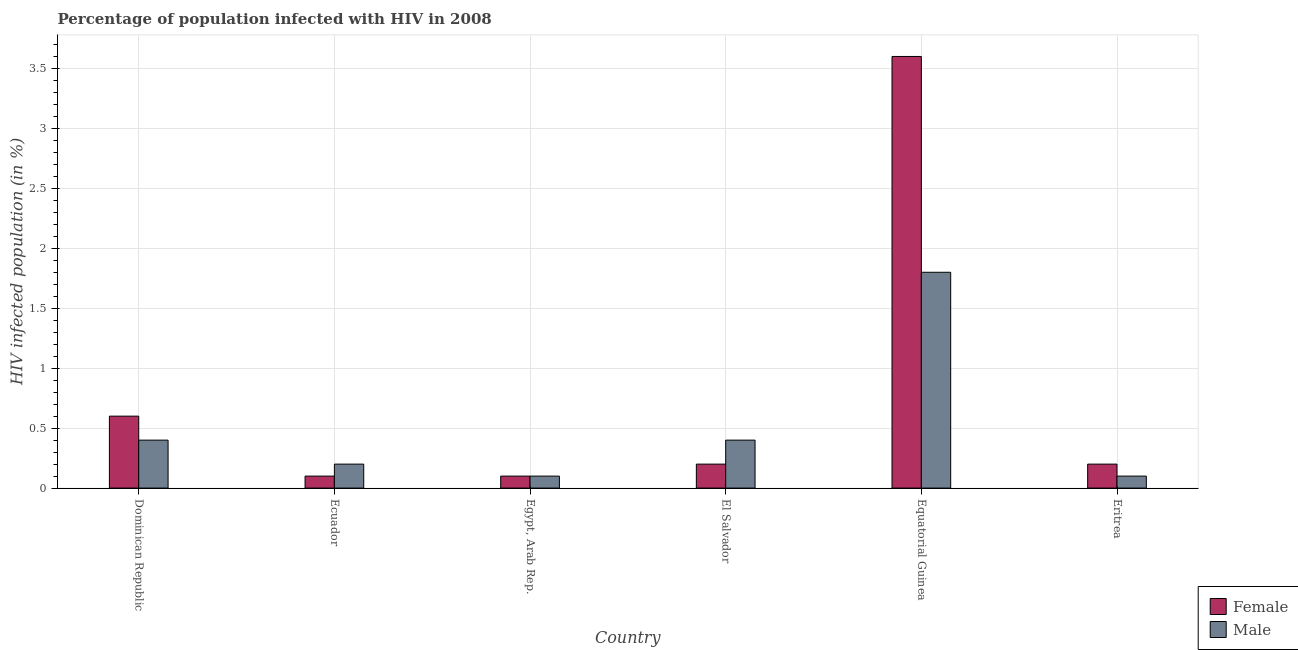How many groups of bars are there?
Keep it short and to the point. 6. How many bars are there on the 1st tick from the right?
Your answer should be compact. 2. What is the label of the 6th group of bars from the left?
Your answer should be very brief. Eritrea. In how many cases, is the number of bars for a given country not equal to the number of legend labels?
Give a very brief answer. 0. Across all countries, what is the minimum percentage of males who are infected with hiv?
Your answer should be very brief. 0.1. In which country was the percentage of males who are infected with hiv maximum?
Make the answer very short. Equatorial Guinea. In which country was the percentage of males who are infected with hiv minimum?
Provide a succinct answer. Egypt, Arab Rep. What is the total percentage of males who are infected with hiv in the graph?
Offer a terse response. 3. What is the difference between the percentage of females who are infected with hiv in Egypt, Arab Rep. and the percentage of males who are infected with hiv in Dominican Republic?
Your answer should be compact. -0.3. What is the average percentage of males who are infected with hiv per country?
Make the answer very short. 0.5. What is the difference between the percentage of males who are infected with hiv and percentage of females who are infected with hiv in El Salvador?
Keep it short and to the point. 0.2. What is the ratio of the percentage of females who are infected with hiv in Egypt, Arab Rep. to that in El Salvador?
Make the answer very short. 0.5. What is the difference between the highest and the second highest percentage of females who are infected with hiv?
Your response must be concise. 3. What is the difference between the highest and the lowest percentage of males who are infected with hiv?
Provide a succinct answer. 1.7. What does the 1st bar from the left in Ecuador represents?
Offer a terse response. Female. Does the graph contain any zero values?
Provide a succinct answer. No. Does the graph contain grids?
Your answer should be very brief. Yes. Where does the legend appear in the graph?
Your answer should be compact. Bottom right. What is the title of the graph?
Your response must be concise. Percentage of population infected with HIV in 2008. Does "Secondary Education" appear as one of the legend labels in the graph?
Make the answer very short. No. What is the label or title of the Y-axis?
Your response must be concise. HIV infected population (in %). What is the HIV infected population (in %) of Female in Dominican Republic?
Offer a very short reply. 0.6. What is the HIV infected population (in %) of Male in Dominican Republic?
Provide a short and direct response. 0.4. What is the HIV infected population (in %) of Female in Ecuador?
Give a very brief answer. 0.1. What is the HIV infected population (in %) in Male in Ecuador?
Provide a short and direct response. 0.2. What is the HIV infected population (in %) in Female in Equatorial Guinea?
Keep it short and to the point. 3.6. What is the HIV infected population (in %) in Male in Equatorial Guinea?
Give a very brief answer. 1.8. Across all countries, what is the minimum HIV infected population (in %) of Male?
Your answer should be very brief. 0.1. What is the total HIV infected population (in %) in Female in the graph?
Your response must be concise. 4.8. What is the difference between the HIV infected population (in %) of Female in Dominican Republic and that in Egypt, Arab Rep.?
Your response must be concise. 0.5. What is the difference between the HIV infected population (in %) of Female in Dominican Republic and that in Equatorial Guinea?
Give a very brief answer. -3. What is the difference between the HIV infected population (in %) in Female in Dominican Republic and that in Eritrea?
Make the answer very short. 0.4. What is the difference between the HIV infected population (in %) of Male in Dominican Republic and that in Eritrea?
Offer a very short reply. 0.3. What is the difference between the HIV infected population (in %) of Female in Ecuador and that in Egypt, Arab Rep.?
Provide a succinct answer. 0. What is the difference between the HIV infected population (in %) in Female in Ecuador and that in Equatorial Guinea?
Your answer should be very brief. -3.5. What is the difference between the HIV infected population (in %) in Male in Ecuador and that in Equatorial Guinea?
Your response must be concise. -1.6. What is the difference between the HIV infected population (in %) in Female in Egypt, Arab Rep. and that in El Salvador?
Provide a succinct answer. -0.1. What is the difference between the HIV infected population (in %) of Male in Egypt, Arab Rep. and that in El Salvador?
Provide a short and direct response. -0.3. What is the difference between the HIV infected population (in %) of Male in Egypt, Arab Rep. and that in Equatorial Guinea?
Your response must be concise. -1.7. What is the difference between the HIV infected population (in %) of Female in El Salvador and that in Equatorial Guinea?
Give a very brief answer. -3.4. What is the difference between the HIV infected population (in %) in Female in Equatorial Guinea and that in Eritrea?
Keep it short and to the point. 3.4. What is the difference between the HIV infected population (in %) in Male in Equatorial Guinea and that in Eritrea?
Offer a very short reply. 1.7. What is the difference between the HIV infected population (in %) of Female in Dominican Republic and the HIV infected population (in %) of Male in Egypt, Arab Rep.?
Offer a terse response. 0.5. What is the difference between the HIV infected population (in %) of Female in Dominican Republic and the HIV infected population (in %) of Male in Equatorial Guinea?
Give a very brief answer. -1.2. What is the difference between the HIV infected population (in %) in Female in Dominican Republic and the HIV infected population (in %) in Male in Eritrea?
Make the answer very short. 0.5. What is the difference between the HIV infected population (in %) of Female in Ecuador and the HIV infected population (in %) of Male in Egypt, Arab Rep.?
Your answer should be compact. 0. What is the difference between the HIV infected population (in %) of Female in Ecuador and the HIV infected population (in %) of Male in El Salvador?
Your answer should be very brief. -0.3. What is the difference between the HIV infected population (in %) of Female in Ecuador and the HIV infected population (in %) of Male in Eritrea?
Make the answer very short. 0. What is the difference between the HIV infected population (in %) of Female in Egypt, Arab Rep. and the HIV infected population (in %) of Male in Equatorial Guinea?
Provide a succinct answer. -1.7. What is the difference between the HIV infected population (in %) in Female in Equatorial Guinea and the HIV infected population (in %) in Male in Eritrea?
Ensure brevity in your answer.  3.5. What is the average HIV infected population (in %) of Female per country?
Ensure brevity in your answer.  0.8. What is the difference between the HIV infected population (in %) of Female and HIV infected population (in %) of Male in El Salvador?
Offer a terse response. -0.2. What is the difference between the HIV infected population (in %) in Female and HIV infected population (in %) in Male in Equatorial Guinea?
Keep it short and to the point. 1.8. What is the ratio of the HIV infected population (in %) of Female in Dominican Republic to that in El Salvador?
Offer a terse response. 3. What is the ratio of the HIV infected population (in %) of Male in Dominican Republic to that in El Salvador?
Offer a terse response. 1. What is the ratio of the HIV infected population (in %) in Female in Dominican Republic to that in Equatorial Guinea?
Provide a succinct answer. 0.17. What is the ratio of the HIV infected population (in %) of Male in Dominican Republic to that in Equatorial Guinea?
Give a very brief answer. 0.22. What is the ratio of the HIV infected population (in %) in Female in Dominican Republic to that in Eritrea?
Your answer should be very brief. 3. What is the ratio of the HIV infected population (in %) of Male in Dominican Republic to that in Eritrea?
Make the answer very short. 4. What is the ratio of the HIV infected population (in %) in Male in Ecuador to that in Egypt, Arab Rep.?
Keep it short and to the point. 2. What is the ratio of the HIV infected population (in %) of Female in Ecuador to that in El Salvador?
Offer a very short reply. 0.5. What is the ratio of the HIV infected population (in %) in Female in Ecuador to that in Equatorial Guinea?
Make the answer very short. 0.03. What is the ratio of the HIV infected population (in %) of Female in Egypt, Arab Rep. to that in El Salvador?
Ensure brevity in your answer.  0.5. What is the ratio of the HIV infected population (in %) in Male in Egypt, Arab Rep. to that in El Salvador?
Your answer should be very brief. 0.25. What is the ratio of the HIV infected population (in %) in Female in Egypt, Arab Rep. to that in Equatorial Guinea?
Give a very brief answer. 0.03. What is the ratio of the HIV infected population (in %) of Male in Egypt, Arab Rep. to that in Equatorial Guinea?
Keep it short and to the point. 0.06. What is the ratio of the HIV infected population (in %) in Female in El Salvador to that in Equatorial Guinea?
Your answer should be very brief. 0.06. What is the ratio of the HIV infected population (in %) of Male in El Salvador to that in Equatorial Guinea?
Your answer should be compact. 0.22. What is the ratio of the HIV infected population (in %) in Female in El Salvador to that in Eritrea?
Ensure brevity in your answer.  1. What is the ratio of the HIV infected population (in %) of Male in Equatorial Guinea to that in Eritrea?
Your response must be concise. 18. What is the difference between the highest and the second highest HIV infected population (in %) of Female?
Offer a very short reply. 3. What is the difference between the highest and the lowest HIV infected population (in %) in Female?
Give a very brief answer. 3.5. What is the difference between the highest and the lowest HIV infected population (in %) of Male?
Your answer should be very brief. 1.7. 